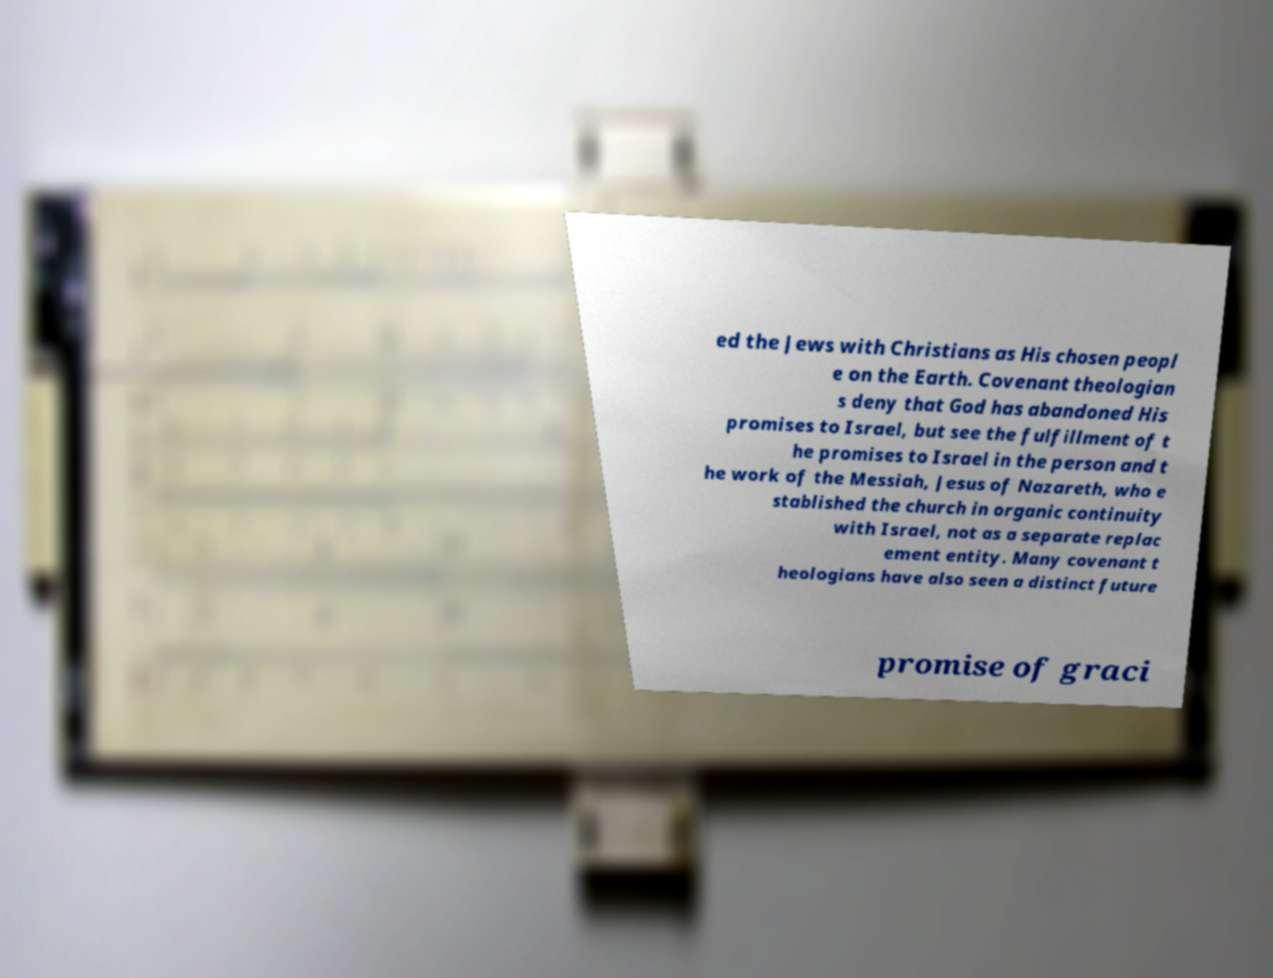Could you extract and type out the text from this image? ed the Jews with Christians as His chosen peopl e on the Earth. Covenant theologian s deny that God has abandoned His promises to Israel, but see the fulfillment of t he promises to Israel in the person and t he work of the Messiah, Jesus of Nazareth, who e stablished the church in organic continuity with Israel, not as a separate replac ement entity. Many covenant t heologians have also seen a distinct future promise of graci 